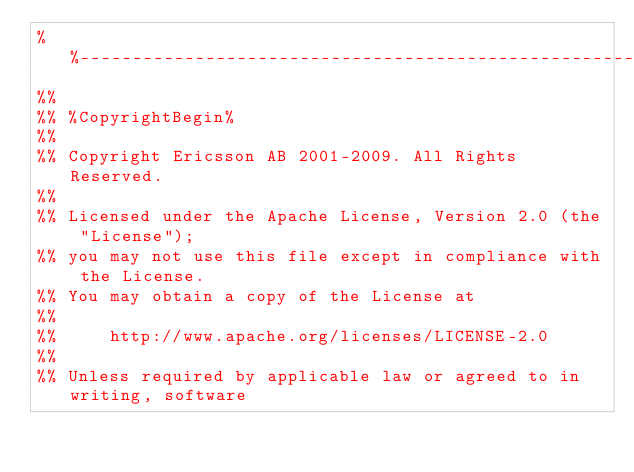Convert code to text. <code><loc_0><loc_0><loc_500><loc_500><_Erlang_>%%--------------------------------------------------------------------
%%
%% %CopyrightBegin%
%% 
%% Copyright Ericsson AB 2001-2009. All Rights Reserved.
%% 
%% Licensed under the Apache License, Version 2.0 (the "License");
%% you may not use this file except in compliance with the License.
%% You may obtain a copy of the License at
%%
%%     http://www.apache.org/licenses/LICENSE-2.0
%%
%% Unless required by applicable law or agreed to in writing, software</code> 